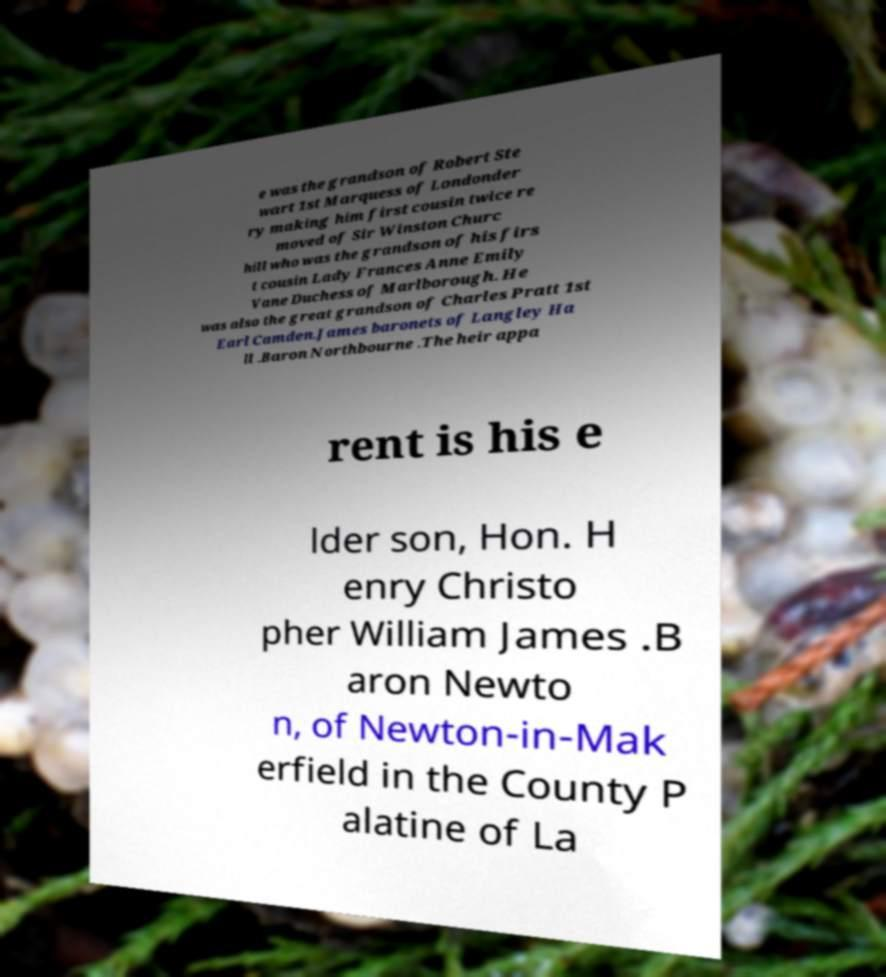For documentation purposes, I need the text within this image transcribed. Could you provide that? e was the grandson of Robert Ste wart 1st Marquess of Londonder ry making him first cousin twice re moved of Sir Winston Churc hill who was the grandson of his firs t cousin Lady Frances Anne Emily Vane Duchess of Marlborough. He was also the great grandson of Charles Pratt 1st Earl Camden.James baronets of Langley Ha ll .Baron Northbourne .The heir appa rent is his e lder son, Hon. H enry Christo pher William James .B aron Newto n, of Newton-in-Mak erfield in the County P alatine of La 